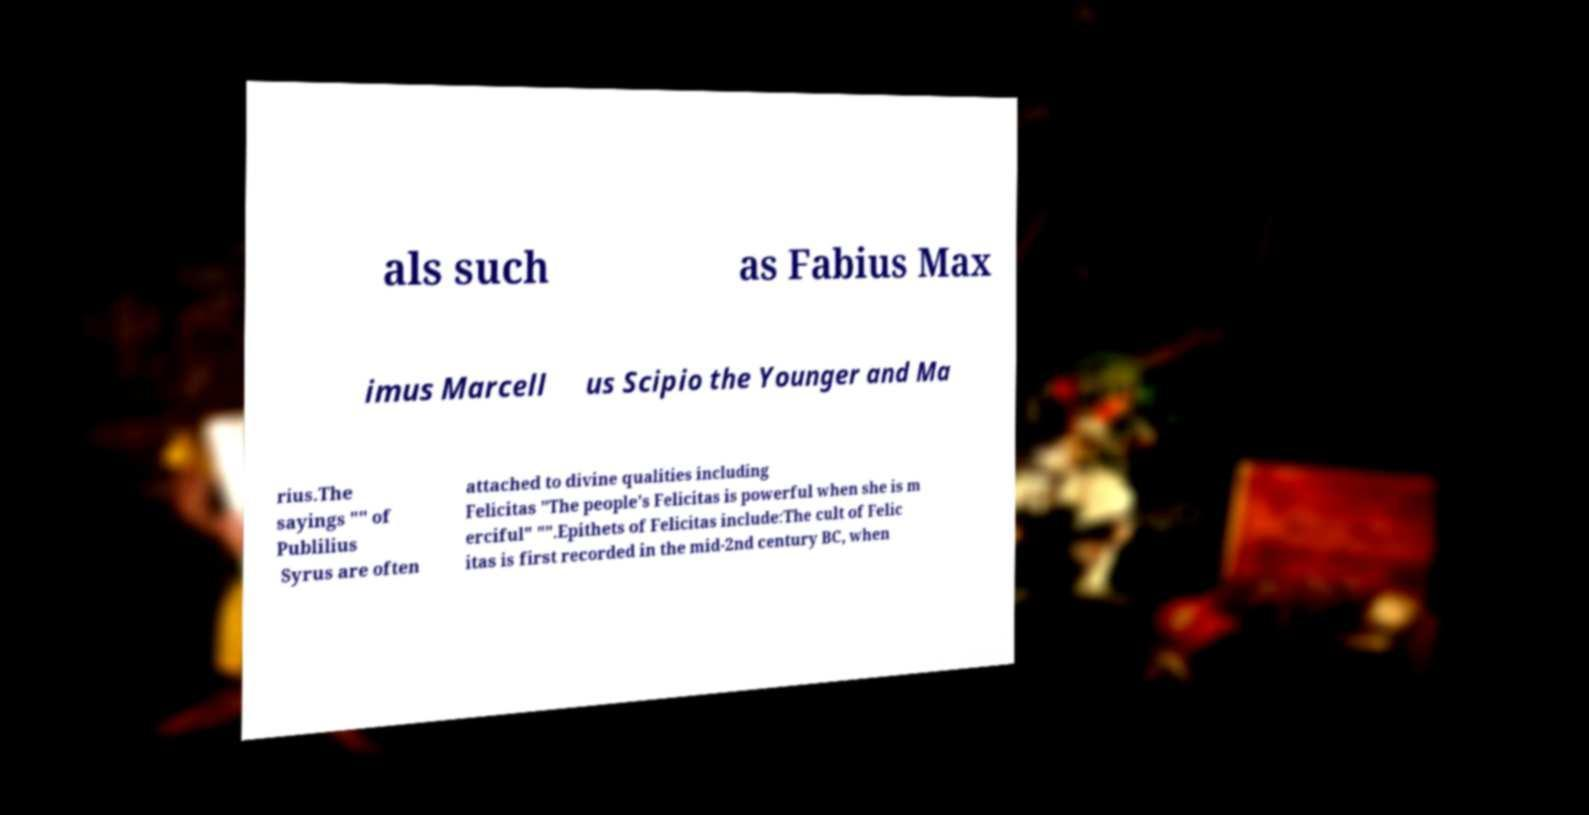Could you extract and type out the text from this image? als such as Fabius Max imus Marcell us Scipio the Younger and Ma rius.The sayings "" of Publilius Syrus are often attached to divine qualities including Felicitas "The people's Felicitas is powerful when she is m erciful" "".Epithets of Felicitas include:The cult of Felic itas is first recorded in the mid-2nd century BC, when 